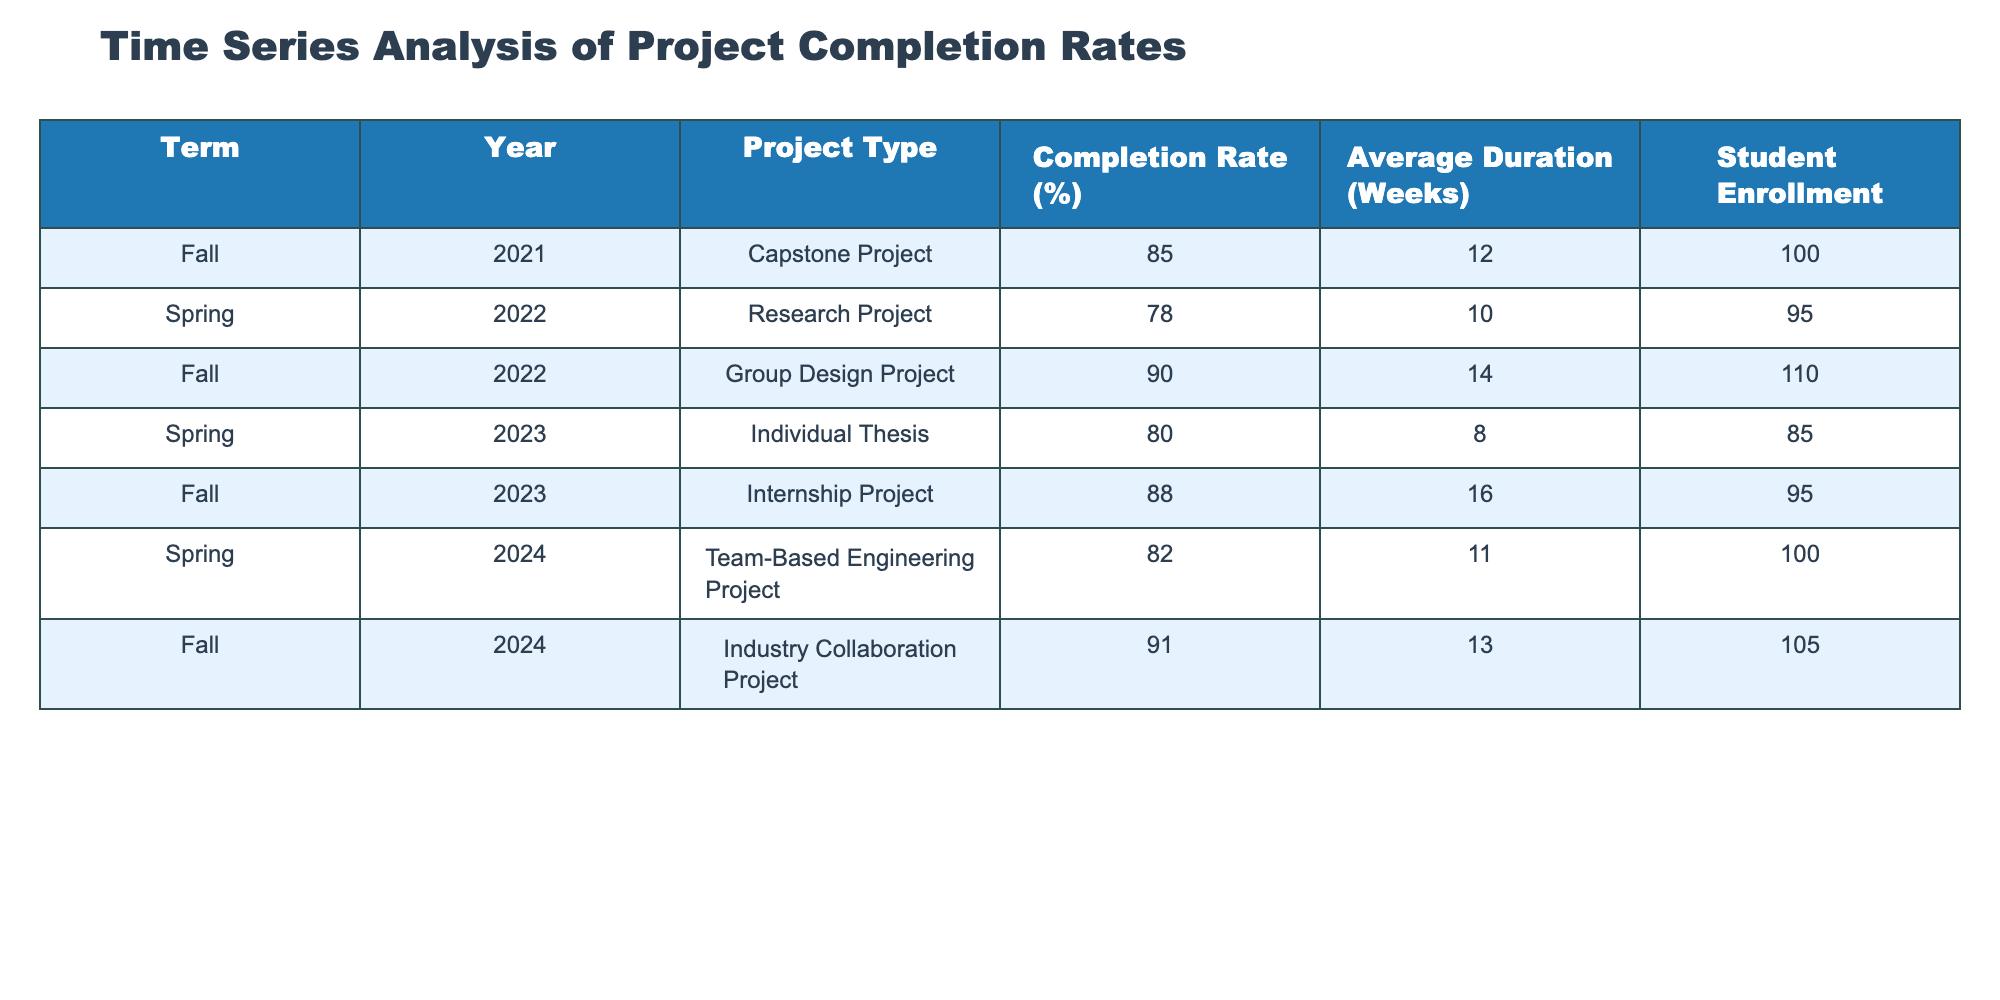What is the completion rate for the Industry Collaboration Project? The completion rate for the Industry Collaboration Project listed in the table is found in the "Completion Rate (%)” column next to "Industry Collaboration Project," which shows 91%.
Answer: 91% What is the average duration of the projects listed in the table? To find the average duration, sum the values in the "Average Duration (Weeks)" column: (12 + 10 + 14 + 8 + 16 + 11 + 13) = 84 weeks, then divide by the number of projects (7) to get an average of 84/7 = 12 weeks.
Answer: 12 weeks Which term had the lowest completion rate? The term with the lowest completion rate can be identified by looking through the "Completion Rate (%)" column. The lowest value is 78%, which corresponds to the Spring 2022 term (Research Project).
Answer: Spring 2022 How many projects had a completion rate above 85%? To find the count of projects with a completion rate above 85%, check the "Completion Rate (%)" column. The entries for Capstone Project (85%), Group Design Project (90%), Internship Project (88%), and Industry Collaboration Project (91%) qualify, totaling 4 projects.
Answer: 4 projects Was the average duration of projects in Fall greater than that in Spring? The average duration for Fall projects: (12 + 14 + 16 + 13) = 55 weeks for 4 projects, which is 55/4 = 13.75 weeks. The Spring projects: (10 + 8 + 11) = 29 weeks for 3 projects, which is 29/3 ≈ 9.67 weeks. Since 13.75 > 9.67, Yes, the average for Fall is greater.
Answer: Yes What is the total student enrollment across all projects in the table? To calculate total enrollment, sum the "Student Enrollment" values: (100 + 95 + 110 + 85 + 95 + 100 + 105) = 790 students.
Answer: 790 students Which project had the longest average duration and what is its duration? The project with the longest average duration is found by reviewing the "Average Duration (Weeks)" column. The Internship Project has the longest duration at 16 weeks.
Answer: Internship Project, 16 weeks How does the completion rate for Individual Thesis compare to Team-Based Engineering Project? The completion rate for Individual Thesis is 80%, while Team-Based Engineering Project has a rate of 82%. Since 80% < 82%, the Team-Based Engineering Project has a higher rate.
Answer: Team-Based Engineering Project is higher What percentage of the projects had completion rates below 80%? Identify the rates below 80% from the "Completion Rate (%)" column. Only the Research Project (78%) meets this criteria; hence, of 7 projects, 1 is below, which is 1/7 = 14.29%.
Answer: 14.29% How many projects involved a student enrollment of 100 or more? Check the "Student Enrollment" column for values 100 or more: Capstone Project (100), Group Design Project (110), Internship Project (95), Industry Collaboration Project (105) show 3 projects with 100 or more.
Answer: 3 projects 